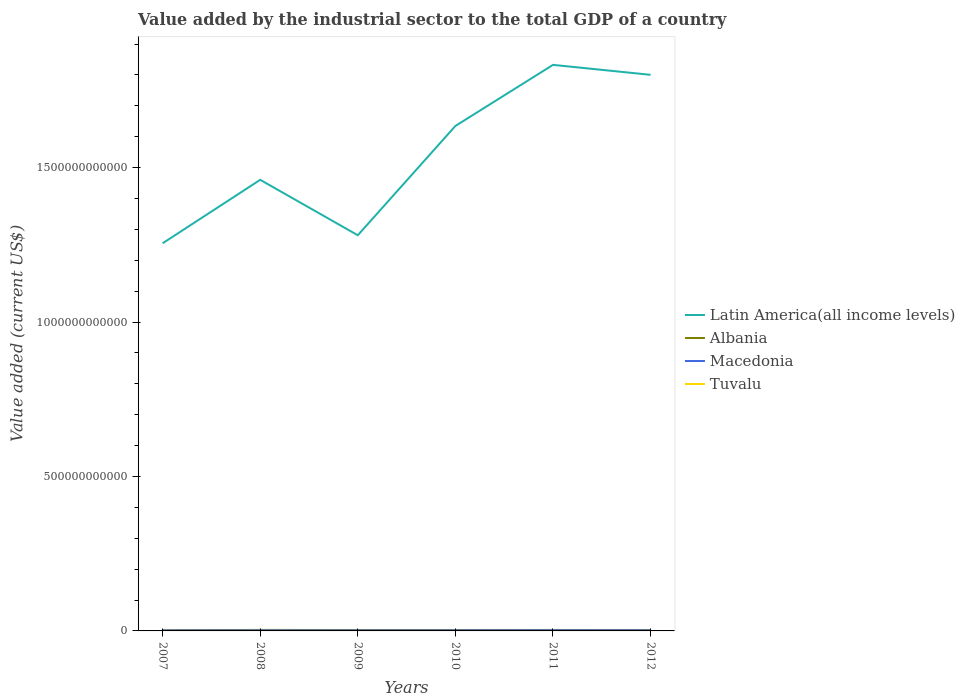Is the number of lines equal to the number of legend labels?
Offer a very short reply. Yes. Across all years, what is the maximum value added by the industrial sector to the total GDP in Macedonia?
Offer a very short reply. 1.72e+09. In which year was the value added by the industrial sector to the total GDP in Macedonia maximum?
Make the answer very short. 2007. What is the total value added by the industrial sector to the total GDP in Macedonia in the graph?
Your answer should be very brief. -2.64e+08. What is the difference between the highest and the second highest value added by the industrial sector to the total GDP in Macedonia?
Ensure brevity in your answer.  5.50e+08. How many lines are there?
Your response must be concise. 4. What is the difference between two consecutive major ticks on the Y-axis?
Your answer should be compact. 5.00e+11. Are the values on the major ticks of Y-axis written in scientific E-notation?
Keep it short and to the point. No. Does the graph contain any zero values?
Provide a succinct answer. No. How many legend labels are there?
Your answer should be compact. 4. How are the legend labels stacked?
Offer a terse response. Vertical. What is the title of the graph?
Your answer should be very brief. Value added by the industrial sector to the total GDP of a country. What is the label or title of the Y-axis?
Your answer should be very brief. Value added (current US$). What is the Value added (current US$) in Latin America(all income levels) in 2007?
Ensure brevity in your answer.  1.26e+12. What is the Value added (current US$) in Albania in 2007?
Your answer should be very brief. 2.34e+09. What is the Value added (current US$) in Macedonia in 2007?
Provide a succinct answer. 1.72e+09. What is the Value added (current US$) in Tuvalu in 2007?
Provide a short and direct response. 2.12e+06. What is the Value added (current US$) of Latin America(all income levels) in 2008?
Provide a succinct answer. 1.46e+12. What is the Value added (current US$) in Albania in 2008?
Offer a terse response. 3.24e+09. What is the Value added (current US$) in Macedonia in 2008?
Give a very brief answer. 1.94e+09. What is the Value added (current US$) in Tuvalu in 2008?
Provide a short and direct response. 3.91e+06. What is the Value added (current US$) in Latin America(all income levels) in 2009?
Your response must be concise. 1.28e+12. What is the Value added (current US$) of Albania in 2009?
Make the answer very short. 2.94e+09. What is the Value added (current US$) of Macedonia in 2009?
Your answer should be very brief. 1.78e+09. What is the Value added (current US$) in Tuvalu in 2009?
Your answer should be compact. 3.10e+06. What is the Value added (current US$) in Latin America(all income levels) in 2010?
Provide a succinct answer. 1.63e+12. What is the Value added (current US$) of Albania in 2010?
Your answer should be compact. 2.97e+09. What is the Value added (current US$) of Macedonia in 2010?
Provide a short and direct response. 1.98e+09. What is the Value added (current US$) of Tuvalu in 2010?
Make the answer very short. 1.77e+06. What is the Value added (current US$) in Latin America(all income levels) in 2011?
Offer a very short reply. 1.83e+12. What is the Value added (current US$) in Albania in 2011?
Your answer should be very brief. 3.16e+09. What is the Value added (current US$) of Macedonia in 2011?
Ensure brevity in your answer.  2.27e+09. What is the Value added (current US$) in Tuvalu in 2011?
Give a very brief answer. 3.49e+06. What is the Value added (current US$) of Latin America(all income levels) in 2012?
Offer a very short reply. 1.80e+12. What is the Value added (current US$) of Albania in 2012?
Offer a very short reply. 2.82e+09. What is the Value added (current US$) in Macedonia in 2012?
Provide a succinct answer. 2.05e+09. What is the Value added (current US$) of Tuvalu in 2012?
Offer a terse response. 2.17e+06. Across all years, what is the maximum Value added (current US$) of Latin America(all income levels)?
Offer a terse response. 1.83e+12. Across all years, what is the maximum Value added (current US$) of Albania?
Offer a very short reply. 3.24e+09. Across all years, what is the maximum Value added (current US$) of Macedonia?
Provide a succinct answer. 2.27e+09. Across all years, what is the maximum Value added (current US$) of Tuvalu?
Make the answer very short. 3.91e+06. Across all years, what is the minimum Value added (current US$) in Latin America(all income levels)?
Your answer should be compact. 1.26e+12. Across all years, what is the minimum Value added (current US$) of Albania?
Offer a terse response. 2.34e+09. Across all years, what is the minimum Value added (current US$) in Macedonia?
Give a very brief answer. 1.72e+09. Across all years, what is the minimum Value added (current US$) in Tuvalu?
Ensure brevity in your answer.  1.77e+06. What is the total Value added (current US$) in Latin America(all income levels) in the graph?
Keep it short and to the point. 9.26e+12. What is the total Value added (current US$) of Albania in the graph?
Your answer should be very brief. 1.75e+1. What is the total Value added (current US$) in Macedonia in the graph?
Provide a succinct answer. 1.17e+1. What is the total Value added (current US$) of Tuvalu in the graph?
Offer a very short reply. 1.65e+07. What is the difference between the Value added (current US$) in Latin America(all income levels) in 2007 and that in 2008?
Offer a very short reply. -2.05e+11. What is the difference between the Value added (current US$) of Albania in 2007 and that in 2008?
Give a very brief answer. -9.05e+08. What is the difference between the Value added (current US$) of Macedonia in 2007 and that in 2008?
Offer a terse response. -2.20e+08. What is the difference between the Value added (current US$) of Tuvalu in 2007 and that in 2008?
Offer a terse response. -1.79e+06. What is the difference between the Value added (current US$) in Latin America(all income levels) in 2007 and that in 2009?
Your response must be concise. -2.60e+1. What is the difference between the Value added (current US$) in Albania in 2007 and that in 2009?
Ensure brevity in your answer.  -6.04e+08. What is the difference between the Value added (current US$) of Macedonia in 2007 and that in 2009?
Your answer should be compact. -6.80e+07. What is the difference between the Value added (current US$) in Tuvalu in 2007 and that in 2009?
Give a very brief answer. -9.82e+05. What is the difference between the Value added (current US$) in Latin America(all income levels) in 2007 and that in 2010?
Ensure brevity in your answer.  -3.80e+11. What is the difference between the Value added (current US$) in Albania in 2007 and that in 2010?
Ensure brevity in your answer.  -6.38e+08. What is the difference between the Value added (current US$) in Macedonia in 2007 and that in 2010?
Offer a very short reply. -2.64e+08. What is the difference between the Value added (current US$) of Tuvalu in 2007 and that in 2010?
Give a very brief answer. 3.43e+05. What is the difference between the Value added (current US$) of Latin America(all income levels) in 2007 and that in 2011?
Offer a very short reply. -5.78e+11. What is the difference between the Value added (current US$) in Albania in 2007 and that in 2011?
Your answer should be very brief. -8.20e+08. What is the difference between the Value added (current US$) of Macedonia in 2007 and that in 2011?
Your response must be concise. -5.50e+08. What is the difference between the Value added (current US$) in Tuvalu in 2007 and that in 2011?
Ensure brevity in your answer.  -1.37e+06. What is the difference between the Value added (current US$) in Latin America(all income levels) in 2007 and that in 2012?
Provide a short and direct response. -5.45e+11. What is the difference between the Value added (current US$) in Albania in 2007 and that in 2012?
Offer a very short reply. -4.87e+08. What is the difference between the Value added (current US$) in Macedonia in 2007 and that in 2012?
Keep it short and to the point. -3.39e+08. What is the difference between the Value added (current US$) in Tuvalu in 2007 and that in 2012?
Provide a succinct answer. -4.91e+04. What is the difference between the Value added (current US$) of Latin America(all income levels) in 2008 and that in 2009?
Your response must be concise. 1.79e+11. What is the difference between the Value added (current US$) of Albania in 2008 and that in 2009?
Provide a succinct answer. 3.01e+08. What is the difference between the Value added (current US$) in Macedonia in 2008 and that in 2009?
Provide a short and direct response. 1.52e+08. What is the difference between the Value added (current US$) of Tuvalu in 2008 and that in 2009?
Keep it short and to the point. 8.09e+05. What is the difference between the Value added (current US$) in Latin America(all income levels) in 2008 and that in 2010?
Provide a short and direct response. -1.74e+11. What is the difference between the Value added (current US$) in Albania in 2008 and that in 2010?
Your response must be concise. 2.67e+08. What is the difference between the Value added (current US$) in Macedonia in 2008 and that in 2010?
Keep it short and to the point. -4.39e+07. What is the difference between the Value added (current US$) in Tuvalu in 2008 and that in 2010?
Make the answer very short. 2.13e+06. What is the difference between the Value added (current US$) in Latin America(all income levels) in 2008 and that in 2011?
Provide a succinct answer. -3.72e+11. What is the difference between the Value added (current US$) of Albania in 2008 and that in 2011?
Provide a succinct answer. 8.48e+07. What is the difference between the Value added (current US$) of Macedonia in 2008 and that in 2011?
Offer a very short reply. -3.30e+08. What is the difference between the Value added (current US$) in Tuvalu in 2008 and that in 2011?
Offer a very short reply. 4.23e+05. What is the difference between the Value added (current US$) in Latin America(all income levels) in 2008 and that in 2012?
Your answer should be compact. -3.40e+11. What is the difference between the Value added (current US$) in Albania in 2008 and that in 2012?
Provide a succinct answer. 4.18e+08. What is the difference between the Value added (current US$) in Macedonia in 2008 and that in 2012?
Provide a succinct answer. -1.19e+08. What is the difference between the Value added (current US$) of Tuvalu in 2008 and that in 2012?
Your answer should be very brief. 1.74e+06. What is the difference between the Value added (current US$) of Latin America(all income levels) in 2009 and that in 2010?
Ensure brevity in your answer.  -3.54e+11. What is the difference between the Value added (current US$) in Albania in 2009 and that in 2010?
Keep it short and to the point. -3.38e+07. What is the difference between the Value added (current US$) in Macedonia in 2009 and that in 2010?
Offer a terse response. -1.96e+08. What is the difference between the Value added (current US$) of Tuvalu in 2009 and that in 2010?
Offer a very short reply. 1.33e+06. What is the difference between the Value added (current US$) of Latin America(all income levels) in 2009 and that in 2011?
Ensure brevity in your answer.  -5.52e+11. What is the difference between the Value added (current US$) of Albania in 2009 and that in 2011?
Make the answer very short. -2.16e+08. What is the difference between the Value added (current US$) of Macedonia in 2009 and that in 2011?
Offer a terse response. -4.82e+08. What is the difference between the Value added (current US$) in Tuvalu in 2009 and that in 2011?
Offer a very short reply. -3.86e+05. What is the difference between the Value added (current US$) in Latin America(all income levels) in 2009 and that in 2012?
Make the answer very short. -5.19e+11. What is the difference between the Value added (current US$) of Albania in 2009 and that in 2012?
Provide a succinct answer. 1.17e+08. What is the difference between the Value added (current US$) in Macedonia in 2009 and that in 2012?
Provide a short and direct response. -2.71e+08. What is the difference between the Value added (current US$) in Tuvalu in 2009 and that in 2012?
Your answer should be compact. 9.33e+05. What is the difference between the Value added (current US$) of Latin America(all income levels) in 2010 and that in 2011?
Keep it short and to the point. -1.98e+11. What is the difference between the Value added (current US$) of Albania in 2010 and that in 2011?
Ensure brevity in your answer.  -1.82e+08. What is the difference between the Value added (current US$) in Macedonia in 2010 and that in 2011?
Make the answer very short. -2.86e+08. What is the difference between the Value added (current US$) of Tuvalu in 2010 and that in 2011?
Keep it short and to the point. -1.71e+06. What is the difference between the Value added (current US$) of Latin America(all income levels) in 2010 and that in 2012?
Your answer should be compact. -1.66e+11. What is the difference between the Value added (current US$) of Albania in 2010 and that in 2012?
Offer a terse response. 1.51e+08. What is the difference between the Value added (current US$) of Macedonia in 2010 and that in 2012?
Your answer should be very brief. -7.48e+07. What is the difference between the Value added (current US$) of Tuvalu in 2010 and that in 2012?
Your answer should be compact. -3.92e+05. What is the difference between the Value added (current US$) of Latin America(all income levels) in 2011 and that in 2012?
Make the answer very short. 3.22e+1. What is the difference between the Value added (current US$) in Albania in 2011 and that in 2012?
Your answer should be very brief. 3.33e+08. What is the difference between the Value added (current US$) in Macedonia in 2011 and that in 2012?
Keep it short and to the point. 2.12e+08. What is the difference between the Value added (current US$) of Tuvalu in 2011 and that in 2012?
Your response must be concise. 1.32e+06. What is the difference between the Value added (current US$) of Latin America(all income levels) in 2007 and the Value added (current US$) of Albania in 2008?
Provide a succinct answer. 1.25e+12. What is the difference between the Value added (current US$) of Latin America(all income levels) in 2007 and the Value added (current US$) of Macedonia in 2008?
Offer a very short reply. 1.25e+12. What is the difference between the Value added (current US$) of Latin America(all income levels) in 2007 and the Value added (current US$) of Tuvalu in 2008?
Offer a very short reply. 1.26e+12. What is the difference between the Value added (current US$) of Albania in 2007 and the Value added (current US$) of Macedonia in 2008?
Make the answer very short. 4.01e+08. What is the difference between the Value added (current US$) in Albania in 2007 and the Value added (current US$) in Tuvalu in 2008?
Your answer should be very brief. 2.33e+09. What is the difference between the Value added (current US$) in Macedonia in 2007 and the Value added (current US$) in Tuvalu in 2008?
Your response must be concise. 1.71e+09. What is the difference between the Value added (current US$) in Latin America(all income levels) in 2007 and the Value added (current US$) in Albania in 2009?
Keep it short and to the point. 1.25e+12. What is the difference between the Value added (current US$) of Latin America(all income levels) in 2007 and the Value added (current US$) of Macedonia in 2009?
Your answer should be very brief. 1.25e+12. What is the difference between the Value added (current US$) in Latin America(all income levels) in 2007 and the Value added (current US$) in Tuvalu in 2009?
Give a very brief answer. 1.26e+12. What is the difference between the Value added (current US$) of Albania in 2007 and the Value added (current US$) of Macedonia in 2009?
Keep it short and to the point. 5.53e+08. What is the difference between the Value added (current US$) in Albania in 2007 and the Value added (current US$) in Tuvalu in 2009?
Keep it short and to the point. 2.33e+09. What is the difference between the Value added (current US$) of Macedonia in 2007 and the Value added (current US$) of Tuvalu in 2009?
Keep it short and to the point. 1.71e+09. What is the difference between the Value added (current US$) in Latin America(all income levels) in 2007 and the Value added (current US$) in Albania in 2010?
Your response must be concise. 1.25e+12. What is the difference between the Value added (current US$) of Latin America(all income levels) in 2007 and the Value added (current US$) of Macedonia in 2010?
Provide a succinct answer. 1.25e+12. What is the difference between the Value added (current US$) of Latin America(all income levels) in 2007 and the Value added (current US$) of Tuvalu in 2010?
Keep it short and to the point. 1.26e+12. What is the difference between the Value added (current US$) in Albania in 2007 and the Value added (current US$) in Macedonia in 2010?
Provide a succinct answer. 3.57e+08. What is the difference between the Value added (current US$) in Albania in 2007 and the Value added (current US$) in Tuvalu in 2010?
Make the answer very short. 2.33e+09. What is the difference between the Value added (current US$) of Macedonia in 2007 and the Value added (current US$) of Tuvalu in 2010?
Keep it short and to the point. 1.71e+09. What is the difference between the Value added (current US$) in Latin America(all income levels) in 2007 and the Value added (current US$) in Albania in 2011?
Your answer should be compact. 1.25e+12. What is the difference between the Value added (current US$) in Latin America(all income levels) in 2007 and the Value added (current US$) in Macedonia in 2011?
Your response must be concise. 1.25e+12. What is the difference between the Value added (current US$) in Latin America(all income levels) in 2007 and the Value added (current US$) in Tuvalu in 2011?
Offer a very short reply. 1.26e+12. What is the difference between the Value added (current US$) of Albania in 2007 and the Value added (current US$) of Macedonia in 2011?
Keep it short and to the point. 7.04e+07. What is the difference between the Value added (current US$) in Albania in 2007 and the Value added (current US$) in Tuvalu in 2011?
Provide a short and direct response. 2.33e+09. What is the difference between the Value added (current US$) of Macedonia in 2007 and the Value added (current US$) of Tuvalu in 2011?
Ensure brevity in your answer.  1.71e+09. What is the difference between the Value added (current US$) of Latin America(all income levels) in 2007 and the Value added (current US$) of Albania in 2012?
Make the answer very short. 1.25e+12. What is the difference between the Value added (current US$) in Latin America(all income levels) in 2007 and the Value added (current US$) in Macedonia in 2012?
Your answer should be compact. 1.25e+12. What is the difference between the Value added (current US$) in Latin America(all income levels) in 2007 and the Value added (current US$) in Tuvalu in 2012?
Give a very brief answer. 1.26e+12. What is the difference between the Value added (current US$) in Albania in 2007 and the Value added (current US$) in Macedonia in 2012?
Your answer should be compact. 2.82e+08. What is the difference between the Value added (current US$) of Albania in 2007 and the Value added (current US$) of Tuvalu in 2012?
Keep it short and to the point. 2.33e+09. What is the difference between the Value added (current US$) in Macedonia in 2007 and the Value added (current US$) in Tuvalu in 2012?
Keep it short and to the point. 1.71e+09. What is the difference between the Value added (current US$) in Latin America(all income levels) in 2008 and the Value added (current US$) in Albania in 2009?
Your answer should be very brief. 1.46e+12. What is the difference between the Value added (current US$) of Latin America(all income levels) in 2008 and the Value added (current US$) of Macedonia in 2009?
Provide a short and direct response. 1.46e+12. What is the difference between the Value added (current US$) in Latin America(all income levels) in 2008 and the Value added (current US$) in Tuvalu in 2009?
Keep it short and to the point. 1.46e+12. What is the difference between the Value added (current US$) of Albania in 2008 and the Value added (current US$) of Macedonia in 2009?
Offer a terse response. 1.46e+09. What is the difference between the Value added (current US$) in Albania in 2008 and the Value added (current US$) in Tuvalu in 2009?
Ensure brevity in your answer.  3.24e+09. What is the difference between the Value added (current US$) of Macedonia in 2008 and the Value added (current US$) of Tuvalu in 2009?
Provide a short and direct response. 1.93e+09. What is the difference between the Value added (current US$) of Latin America(all income levels) in 2008 and the Value added (current US$) of Albania in 2010?
Provide a succinct answer. 1.46e+12. What is the difference between the Value added (current US$) in Latin America(all income levels) in 2008 and the Value added (current US$) in Macedonia in 2010?
Offer a terse response. 1.46e+12. What is the difference between the Value added (current US$) in Latin America(all income levels) in 2008 and the Value added (current US$) in Tuvalu in 2010?
Your answer should be very brief. 1.46e+12. What is the difference between the Value added (current US$) of Albania in 2008 and the Value added (current US$) of Macedonia in 2010?
Your answer should be very brief. 1.26e+09. What is the difference between the Value added (current US$) in Albania in 2008 and the Value added (current US$) in Tuvalu in 2010?
Keep it short and to the point. 3.24e+09. What is the difference between the Value added (current US$) of Macedonia in 2008 and the Value added (current US$) of Tuvalu in 2010?
Keep it short and to the point. 1.93e+09. What is the difference between the Value added (current US$) in Latin America(all income levels) in 2008 and the Value added (current US$) in Albania in 2011?
Your answer should be very brief. 1.46e+12. What is the difference between the Value added (current US$) in Latin America(all income levels) in 2008 and the Value added (current US$) in Macedonia in 2011?
Provide a succinct answer. 1.46e+12. What is the difference between the Value added (current US$) in Latin America(all income levels) in 2008 and the Value added (current US$) in Tuvalu in 2011?
Your answer should be compact. 1.46e+12. What is the difference between the Value added (current US$) in Albania in 2008 and the Value added (current US$) in Macedonia in 2011?
Keep it short and to the point. 9.75e+08. What is the difference between the Value added (current US$) of Albania in 2008 and the Value added (current US$) of Tuvalu in 2011?
Offer a very short reply. 3.24e+09. What is the difference between the Value added (current US$) in Macedonia in 2008 and the Value added (current US$) in Tuvalu in 2011?
Ensure brevity in your answer.  1.93e+09. What is the difference between the Value added (current US$) in Latin America(all income levels) in 2008 and the Value added (current US$) in Albania in 2012?
Your answer should be very brief. 1.46e+12. What is the difference between the Value added (current US$) of Latin America(all income levels) in 2008 and the Value added (current US$) of Macedonia in 2012?
Make the answer very short. 1.46e+12. What is the difference between the Value added (current US$) in Latin America(all income levels) in 2008 and the Value added (current US$) in Tuvalu in 2012?
Provide a short and direct response. 1.46e+12. What is the difference between the Value added (current US$) of Albania in 2008 and the Value added (current US$) of Macedonia in 2012?
Offer a terse response. 1.19e+09. What is the difference between the Value added (current US$) of Albania in 2008 and the Value added (current US$) of Tuvalu in 2012?
Give a very brief answer. 3.24e+09. What is the difference between the Value added (current US$) in Macedonia in 2008 and the Value added (current US$) in Tuvalu in 2012?
Your answer should be very brief. 1.93e+09. What is the difference between the Value added (current US$) of Latin America(all income levels) in 2009 and the Value added (current US$) of Albania in 2010?
Make the answer very short. 1.28e+12. What is the difference between the Value added (current US$) in Latin America(all income levels) in 2009 and the Value added (current US$) in Macedonia in 2010?
Give a very brief answer. 1.28e+12. What is the difference between the Value added (current US$) of Latin America(all income levels) in 2009 and the Value added (current US$) of Tuvalu in 2010?
Give a very brief answer. 1.28e+12. What is the difference between the Value added (current US$) of Albania in 2009 and the Value added (current US$) of Macedonia in 2010?
Your answer should be very brief. 9.61e+08. What is the difference between the Value added (current US$) of Albania in 2009 and the Value added (current US$) of Tuvalu in 2010?
Keep it short and to the point. 2.94e+09. What is the difference between the Value added (current US$) of Macedonia in 2009 and the Value added (current US$) of Tuvalu in 2010?
Keep it short and to the point. 1.78e+09. What is the difference between the Value added (current US$) in Latin America(all income levels) in 2009 and the Value added (current US$) in Albania in 2011?
Make the answer very short. 1.28e+12. What is the difference between the Value added (current US$) of Latin America(all income levels) in 2009 and the Value added (current US$) of Macedonia in 2011?
Offer a very short reply. 1.28e+12. What is the difference between the Value added (current US$) in Latin America(all income levels) in 2009 and the Value added (current US$) in Tuvalu in 2011?
Provide a short and direct response. 1.28e+12. What is the difference between the Value added (current US$) of Albania in 2009 and the Value added (current US$) of Macedonia in 2011?
Offer a terse response. 6.74e+08. What is the difference between the Value added (current US$) of Albania in 2009 and the Value added (current US$) of Tuvalu in 2011?
Give a very brief answer. 2.94e+09. What is the difference between the Value added (current US$) in Macedonia in 2009 and the Value added (current US$) in Tuvalu in 2011?
Provide a succinct answer. 1.78e+09. What is the difference between the Value added (current US$) in Latin America(all income levels) in 2009 and the Value added (current US$) in Albania in 2012?
Your answer should be compact. 1.28e+12. What is the difference between the Value added (current US$) in Latin America(all income levels) in 2009 and the Value added (current US$) in Macedonia in 2012?
Give a very brief answer. 1.28e+12. What is the difference between the Value added (current US$) of Latin America(all income levels) in 2009 and the Value added (current US$) of Tuvalu in 2012?
Offer a very short reply. 1.28e+12. What is the difference between the Value added (current US$) of Albania in 2009 and the Value added (current US$) of Macedonia in 2012?
Your answer should be compact. 8.86e+08. What is the difference between the Value added (current US$) of Albania in 2009 and the Value added (current US$) of Tuvalu in 2012?
Your answer should be compact. 2.94e+09. What is the difference between the Value added (current US$) of Macedonia in 2009 and the Value added (current US$) of Tuvalu in 2012?
Give a very brief answer. 1.78e+09. What is the difference between the Value added (current US$) of Latin America(all income levels) in 2010 and the Value added (current US$) of Albania in 2011?
Your response must be concise. 1.63e+12. What is the difference between the Value added (current US$) in Latin America(all income levels) in 2010 and the Value added (current US$) in Macedonia in 2011?
Ensure brevity in your answer.  1.63e+12. What is the difference between the Value added (current US$) in Latin America(all income levels) in 2010 and the Value added (current US$) in Tuvalu in 2011?
Your response must be concise. 1.63e+12. What is the difference between the Value added (current US$) in Albania in 2010 and the Value added (current US$) in Macedonia in 2011?
Provide a succinct answer. 7.08e+08. What is the difference between the Value added (current US$) in Albania in 2010 and the Value added (current US$) in Tuvalu in 2011?
Provide a succinct answer. 2.97e+09. What is the difference between the Value added (current US$) of Macedonia in 2010 and the Value added (current US$) of Tuvalu in 2011?
Provide a succinct answer. 1.98e+09. What is the difference between the Value added (current US$) of Latin America(all income levels) in 2010 and the Value added (current US$) of Albania in 2012?
Your response must be concise. 1.63e+12. What is the difference between the Value added (current US$) of Latin America(all income levels) in 2010 and the Value added (current US$) of Macedonia in 2012?
Offer a terse response. 1.63e+12. What is the difference between the Value added (current US$) of Latin America(all income levels) in 2010 and the Value added (current US$) of Tuvalu in 2012?
Give a very brief answer. 1.63e+12. What is the difference between the Value added (current US$) in Albania in 2010 and the Value added (current US$) in Macedonia in 2012?
Keep it short and to the point. 9.20e+08. What is the difference between the Value added (current US$) of Albania in 2010 and the Value added (current US$) of Tuvalu in 2012?
Your answer should be very brief. 2.97e+09. What is the difference between the Value added (current US$) of Macedonia in 2010 and the Value added (current US$) of Tuvalu in 2012?
Your response must be concise. 1.98e+09. What is the difference between the Value added (current US$) in Latin America(all income levels) in 2011 and the Value added (current US$) in Albania in 2012?
Offer a terse response. 1.83e+12. What is the difference between the Value added (current US$) in Latin America(all income levels) in 2011 and the Value added (current US$) in Macedonia in 2012?
Ensure brevity in your answer.  1.83e+12. What is the difference between the Value added (current US$) of Latin America(all income levels) in 2011 and the Value added (current US$) of Tuvalu in 2012?
Your answer should be very brief. 1.83e+12. What is the difference between the Value added (current US$) in Albania in 2011 and the Value added (current US$) in Macedonia in 2012?
Provide a succinct answer. 1.10e+09. What is the difference between the Value added (current US$) of Albania in 2011 and the Value added (current US$) of Tuvalu in 2012?
Provide a short and direct response. 3.15e+09. What is the difference between the Value added (current US$) in Macedonia in 2011 and the Value added (current US$) in Tuvalu in 2012?
Give a very brief answer. 2.26e+09. What is the average Value added (current US$) of Latin America(all income levels) per year?
Make the answer very short. 1.54e+12. What is the average Value added (current US$) of Albania per year?
Your answer should be compact. 2.91e+09. What is the average Value added (current US$) of Macedonia per year?
Your answer should be compact. 1.96e+09. What is the average Value added (current US$) in Tuvalu per year?
Keep it short and to the point. 2.76e+06. In the year 2007, what is the difference between the Value added (current US$) of Latin America(all income levels) and Value added (current US$) of Albania?
Offer a terse response. 1.25e+12. In the year 2007, what is the difference between the Value added (current US$) of Latin America(all income levels) and Value added (current US$) of Macedonia?
Provide a succinct answer. 1.25e+12. In the year 2007, what is the difference between the Value added (current US$) in Latin America(all income levels) and Value added (current US$) in Tuvalu?
Your response must be concise. 1.26e+12. In the year 2007, what is the difference between the Value added (current US$) of Albania and Value added (current US$) of Macedonia?
Give a very brief answer. 6.21e+08. In the year 2007, what is the difference between the Value added (current US$) in Albania and Value added (current US$) in Tuvalu?
Give a very brief answer. 2.33e+09. In the year 2007, what is the difference between the Value added (current US$) of Macedonia and Value added (current US$) of Tuvalu?
Give a very brief answer. 1.71e+09. In the year 2008, what is the difference between the Value added (current US$) of Latin America(all income levels) and Value added (current US$) of Albania?
Offer a terse response. 1.46e+12. In the year 2008, what is the difference between the Value added (current US$) in Latin America(all income levels) and Value added (current US$) in Macedonia?
Offer a terse response. 1.46e+12. In the year 2008, what is the difference between the Value added (current US$) in Latin America(all income levels) and Value added (current US$) in Tuvalu?
Keep it short and to the point. 1.46e+12. In the year 2008, what is the difference between the Value added (current US$) in Albania and Value added (current US$) in Macedonia?
Ensure brevity in your answer.  1.31e+09. In the year 2008, what is the difference between the Value added (current US$) in Albania and Value added (current US$) in Tuvalu?
Provide a succinct answer. 3.24e+09. In the year 2008, what is the difference between the Value added (current US$) of Macedonia and Value added (current US$) of Tuvalu?
Provide a short and direct response. 1.93e+09. In the year 2009, what is the difference between the Value added (current US$) in Latin America(all income levels) and Value added (current US$) in Albania?
Make the answer very short. 1.28e+12. In the year 2009, what is the difference between the Value added (current US$) in Latin America(all income levels) and Value added (current US$) in Macedonia?
Provide a succinct answer. 1.28e+12. In the year 2009, what is the difference between the Value added (current US$) of Latin America(all income levels) and Value added (current US$) of Tuvalu?
Offer a terse response. 1.28e+12. In the year 2009, what is the difference between the Value added (current US$) of Albania and Value added (current US$) of Macedonia?
Your response must be concise. 1.16e+09. In the year 2009, what is the difference between the Value added (current US$) in Albania and Value added (current US$) in Tuvalu?
Ensure brevity in your answer.  2.94e+09. In the year 2009, what is the difference between the Value added (current US$) in Macedonia and Value added (current US$) in Tuvalu?
Provide a short and direct response. 1.78e+09. In the year 2010, what is the difference between the Value added (current US$) of Latin America(all income levels) and Value added (current US$) of Albania?
Give a very brief answer. 1.63e+12. In the year 2010, what is the difference between the Value added (current US$) of Latin America(all income levels) and Value added (current US$) of Macedonia?
Ensure brevity in your answer.  1.63e+12. In the year 2010, what is the difference between the Value added (current US$) in Latin America(all income levels) and Value added (current US$) in Tuvalu?
Your response must be concise. 1.63e+12. In the year 2010, what is the difference between the Value added (current US$) in Albania and Value added (current US$) in Macedonia?
Offer a terse response. 9.95e+08. In the year 2010, what is the difference between the Value added (current US$) of Albania and Value added (current US$) of Tuvalu?
Provide a succinct answer. 2.97e+09. In the year 2010, what is the difference between the Value added (current US$) of Macedonia and Value added (current US$) of Tuvalu?
Offer a very short reply. 1.98e+09. In the year 2011, what is the difference between the Value added (current US$) of Latin America(all income levels) and Value added (current US$) of Albania?
Offer a terse response. 1.83e+12. In the year 2011, what is the difference between the Value added (current US$) in Latin America(all income levels) and Value added (current US$) in Macedonia?
Make the answer very short. 1.83e+12. In the year 2011, what is the difference between the Value added (current US$) of Latin America(all income levels) and Value added (current US$) of Tuvalu?
Ensure brevity in your answer.  1.83e+12. In the year 2011, what is the difference between the Value added (current US$) in Albania and Value added (current US$) in Macedonia?
Your response must be concise. 8.90e+08. In the year 2011, what is the difference between the Value added (current US$) of Albania and Value added (current US$) of Tuvalu?
Provide a short and direct response. 3.15e+09. In the year 2011, what is the difference between the Value added (current US$) of Macedonia and Value added (current US$) of Tuvalu?
Offer a very short reply. 2.26e+09. In the year 2012, what is the difference between the Value added (current US$) of Latin America(all income levels) and Value added (current US$) of Albania?
Provide a short and direct response. 1.80e+12. In the year 2012, what is the difference between the Value added (current US$) in Latin America(all income levels) and Value added (current US$) in Macedonia?
Give a very brief answer. 1.80e+12. In the year 2012, what is the difference between the Value added (current US$) in Latin America(all income levels) and Value added (current US$) in Tuvalu?
Offer a terse response. 1.80e+12. In the year 2012, what is the difference between the Value added (current US$) in Albania and Value added (current US$) in Macedonia?
Your response must be concise. 7.69e+08. In the year 2012, what is the difference between the Value added (current US$) in Albania and Value added (current US$) in Tuvalu?
Provide a short and direct response. 2.82e+09. In the year 2012, what is the difference between the Value added (current US$) in Macedonia and Value added (current US$) in Tuvalu?
Offer a very short reply. 2.05e+09. What is the ratio of the Value added (current US$) of Latin America(all income levels) in 2007 to that in 2008?
Your response must be concise. 0.86. What is the ratio of the Value added (current US$) of Albania in 2007 to that in 2008?
Ensure brevity in your answer.  0.72. What is the ratio of the Value added (current US$) in Macedonia in 2007 to that in 2008?
Offer a very short reply. 0.89. What is the ratio of the Value added (current US$) of Tuvalu in 2007 to that in 2008?
Make the answer very short. 0.54. What is the ratio of the Value added (current US$) in Latin America(all income levels) in 2007 to that in 2009?
Your response must be concise. 0.98. What is the ratio of the Value added (current US$) in Albania in 2007 to that in 2009?
Your answer should be very brief. 0.79. What is the ratio of the Value added (current US$) in Macedonia in 2007 to that in 2009?
Your response must be concise. 0.96. What is the ratio of the Value added (current US$) in Tuvalu in 2007 to that in 2009?
Offer a very short reply. 0.68. What is the ratio of the Value added (current US$) of Latin America(all income levels) in 2007 to that in 2010?
Keep it short and to the point. 0.77. What is the ratio of the Value added (current US$) in Albania in 2007 to that in 2010?
Make the answer very short. 0.79. What is the ratio of the Value added (current US$) in Macedonia in 2007 to that in 2010?
Make the answer very short. 0.87. What is the ratio of the Value added (current US$) of Tuvalu in 2007 to that in 2010?
Keep it short and to the point. 1.19. What is the ratio of the Value added (current US$) in Latin America(all income levels) in 2007 to that in 2011?
Provide a short and direct response. 0.68. What is the ratio of the Value added (current US$) in Albania in 2007 to that in 2011?
Make the answer very short. 0.74. What is the ratio of the Value added (current US$) of Macedonia in 2007 to that in 2011?
Offer a terse response. 0.76. What is the ratio of the Value added (current US$) in Tuvalu in 2007 to that in 2011?
Ensure brevity in your answer.  0.61. What is the ratio of the Value added (current US$) in Latin America(all income levels) in 2007 to that in 2012?
Offer a terse response. 0.7. What is the ratio of the Value added (current US$) in Albania in 2007 to that in 2012?
Provide a succinct answer. 0.83. What is the ratio of the Value added (current US$) in Macedonia in 2007 to that in 2012?
Ensure brevity in your answer.  0.84. What is the ratio of the Value added (current US$) of Tuvalu in 2007 to that in 2012?
Offer a terse response. 0.98. What is the ratio of the Value added (current US$) of Latin America(all income levels) in 2008 to that in 2009?
Give a very brief answer. 1.14. What is the ratio of the Value added (current US$) in Albania in 2008 to that in 2009?
Offer a very short reply. 1.1. What is the ratio of the Value added (current US$) of Macedonia in 2008 to that in 2009?
Provide a short and direct response. 1.09. What is the ratio of the Value added (current US$) of Tuvalu in 2008 to that in 2009?
Offer a very short reply. 1.26. What is the ratio of the Value added (current US$) of Latin America(all income levels) in 2008 to that in 2010?
Offer a terse response. 0.89. What is the ratio of the Value added (current US$) of Albania in 2008 to that in 2010?
Keep it short and to the point. 1.09. What is the ratio of the Value added (current US$) of Macedonia in 2008 to that in 2010?
Ensure brevity in your answer.  0.98. What is the ratio of the Value added (current US$) of Tuvalu in 2008 to that in 2010?
Provide a succinct answer. 2.2. What is the ratio of the Value added (current US$) in Latin America(all income levels) in 2008 to that in 2011?
Provide a short and direct response. 0.8. What is the ratio of the Value added (current US$) of Albania in 2008 to that in 2011?
Offer a very short reply. 1.03. What is the ratio of the Value added (current US$) of Macedonia in 2008 to that in 2011?
Your response must be concise. 0.85. What is the ratio of the Value added (current US$) in Tuvalu in 2008 to that in 2011?
Keep it short and to the point. 1.12. What is the ratio of the Value added (current US$) in Latin America(all income levels) in 2008 to that in 2012?
Offer a very short reply. 0.81. What is the ratio of the Value added (current US$) of Albania in 2008 to that in 2012?
Give a very brief answer. 1.15. What is the ratio of the Value added (current US$) of Macedonia in 2008 to that in 2012?
Provide a succinct answer. 0.94. What is the ratio of the Value added (current US$) of Tuvalu in 2008 to that in 2012?
Provide a succinct answer. 1.8. What is the ratio of the Value added (current US$) in Latin America(all income levels) in 2009 to that in 2010?
Your response must be concise. 0.78. What is the ratio of the Value added (current US$) in Macedonia in 2009 to that in 2010?
Ensure brevity in your answer.  0.9. What is the ratio of the Value added (current US$) in Tuvalu in 2009 to that in 2010?
Keep it short and to the point. 1.75. What is the ratio of the Value added (current US$) in Latin America(all income levels) in 2009 to that in 2011?
Your response must be concise. 0.7. What is the ratio of the Value added (current US$) in Albania in 2009 to that in 2011?
Provide a short and direct response. 0.93. What is the ratio of the Value added (current US$) in Macedonia in 2009 to that in 2011?
Provide a succinct answer. 0.79. What is the ratio of the Value added (current US$) in Tuvalu in 2009 to that in 2011?
Your response must be concise. 0.89. What is the ratio of the Value added (current US$) of Latin America(all income levels) in 2009 to that in 2012?
Offer a very short reply. 0.71. What is the ratio of the Value added (current US$) of Albania in 2009 to that in 2012?
Make the answer very short. 1.04. What is the ratio of the Value added (current US$) of Macedonia in 2009 to that in 2012?
Provide a short and direct response. 0.87. What is the ratio of the Value added (current US$) of Tuvalu in 2009 to that in 2012?
Keep it short and to the point. 1.43. What is the ratio of the Value added (current US$) in Latin America(all income levels) in 2010 to that in 2011?
Offer a very short reply. 0.89. What is the ratio of the Value added (current US$) of Albania in 2010 to that in 2011?
Ensure brevity in your answer.  0.94. What is the ratio of the Value added (current US$) in Macedonia in 2010 to that in 2011?
Your response must be concise. 0.87. What is the ratio of the Value added (current US$) of Tuvalu in 2010 to that in 2011?
Offer a terse response. 0.51. What is the ratio of the Value added (current US$) in Latin America(all income levels) in 2010 to that in 2012?
Keep it short and to the point. 0.91. What is the ratio of the Value added (current US$) in Albania in 2010 to that in 2012?
Offer a very short reply. 1.05. What is the ratio of the Value added (current US$) in Macedonia in 2010 to that in 2012?
Ensure brevity in your answer.  0.96. What is the ratio of the Value added (current US$) of Tuvalu in 2010 to that in 2012?
Offer a very short reply. 0.82. What is the ratio of the Value added (current US$) in Latin America(all income levels) in 2011 to that in 2012?
Give a very brief answer. 1.02. What is the ratio of the Value added (current US$) in Albania in 2011 to that in 2012?
Your answer should be very brief. 1.12. What is the ratio of the Value added (current US$) of Macedonia in 2011 to that in 2012?
Offer a very short reply. 1.1. What is the ratio of the Value added (current US$) in Tuvalu in 2011 to that in 2012?
Make the answer very short. 1.61. What is the difference between the highest and the second highest Value added (current US$) of Latin America(all income levels)?
Offer a very short reply. 3.22e+1. What is the difference between the highest and the second highest Value added (current US$) of Albania?
Give a very brief answer. 8.48e+07. What is the difference between the highest and the second highest Value added (current US$) in Macedonia?
Your answer should be compact. 2.12e+08. What is the difference between the highest and the second highest Value added (current US$) of Tuvalu?
Provide a succinct answer. 4.23e+05. What is the difference between the highest and the lowest Value added (current US$) of Latin America(all income levels)?
Provide a succinct answer. 5.78e+11. What is the difference between the highest and the lowest Value added (current US$) of Albania?
Offer a terse response. 9.05e+08. What is the difference between the highest and the lowest Value added (current US$) in Macedonia?
Your response must be concise. 5.50e+08. What is the difference between the highest and the lowest Value added (current US$) in Tuvalu?
Give a very brief answer. 2.13e+06. 